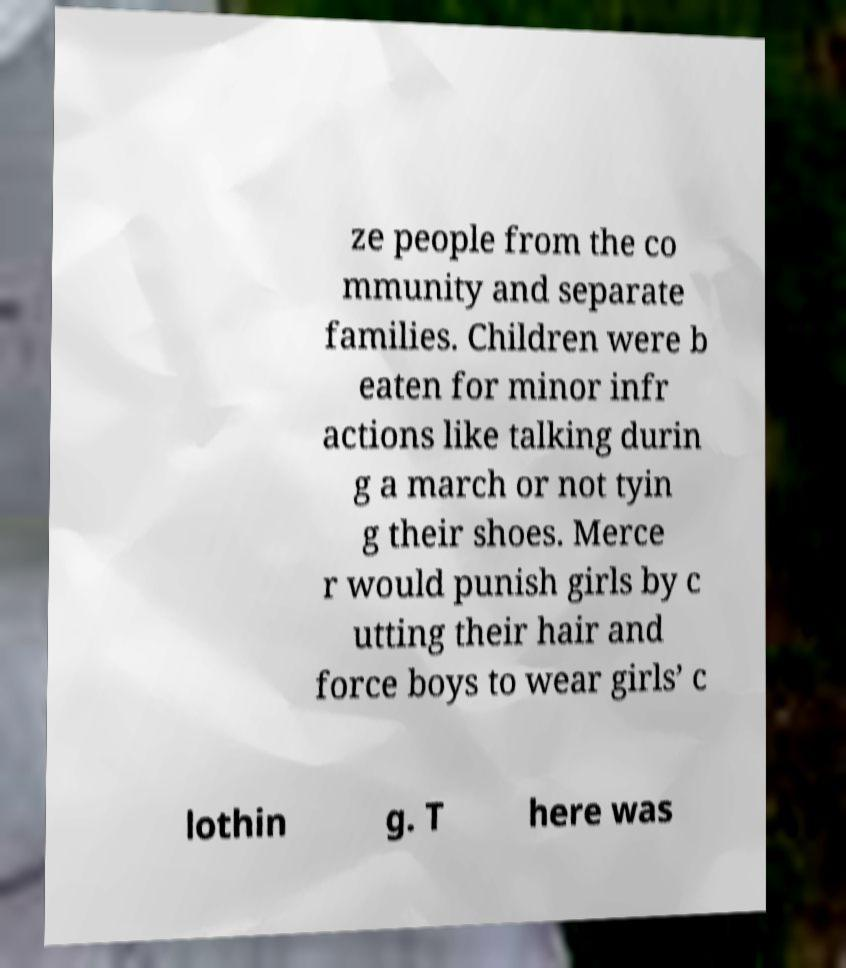Please read and relay the text visible in this image. What does it say? ze people from the co mmunity and separate families. Children were b eaten for minor infr actions like talking durin g a march or not tyin g their shoes. Merce r would punish girls by c utting their hair and force boys to wear girls’ c lothin g. T here was 